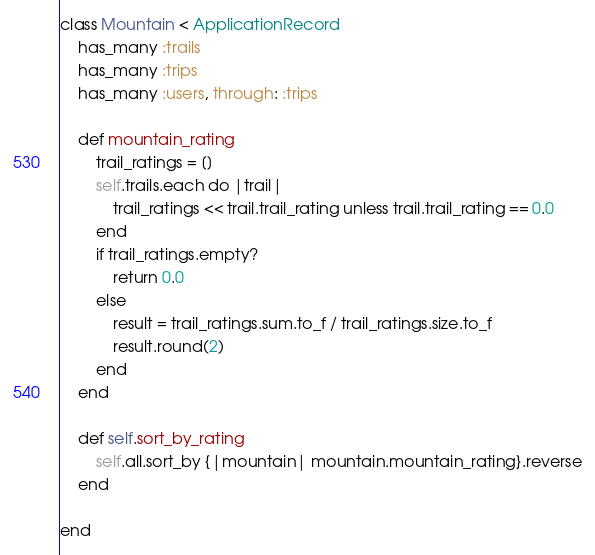Convert code to text. <code><loc_0><loc_0><loc_500><loc_500><_Ruby_>class Mountain < ApplicationRecord
    has_many :trails
    has_many :trips
    has_many :users, through: :trips

    def mountain_rating
        trail_ratings = []
        self.trails.each do |trail|
            trail_ratings << trail.trail_rating unless trail.trail_rating == 0.0
        end
        if trail_ratings.empty?
            return 0.0
        else
            result = trail_ratings.sum.to_f / trail_ratings.size.to_f
            result.round(2)
        end
    end

    def self.sort_by_rating
        self.all.sort_by {|mountain| mountain.mountain_rating}.reverse
    end

end
</code> 